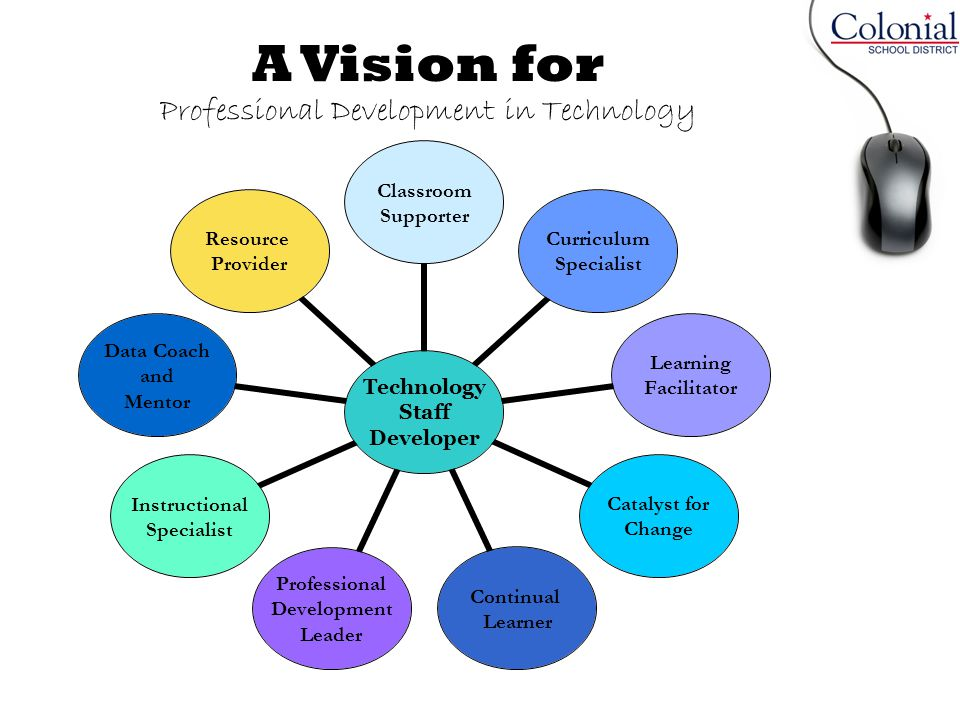How might the role of 'Learning Facilitator' contribute to creating an inclusive learning environment with the help of technology? The 'Learning Facilitator' plays a pivotal role in creating an inclusive learning environment by leveraging technology to accommodate diverse learning needs. They might implement adaptive learning software that adjusts to each student's pace and level of understanding, ensuring that all students receive personalized instruction. Additionally, they can promote the use of digital collaboration tools to foster a sense of community among students, encouraging participation from those who might be less inclined to speak up in a traditional classroom setting. By incorporating multimedia resources, the Learning Facilitator can also make content more accessible and engaging for students with different learning preferences and abilities. Can you give an example of a multimedia resource that might be particularly effective in engaging students? A particularly effective multimedia resource for engaging students could be interactive simulations or educational games. For instance, in a science class, students might use a virtual lab simulation to conduct experiments. This allows students to explore complex concepts in a hands-on, interactive manner without the limitations of physical lab space or resources. These simulations can provide immediate feedback and allow students to learn from trial and error, which is both engaging and educational. Additionally, digital storytelling tools, where students create their own multimedia presentations or videos, can help them to better understand and retain the subject matter by encouraging them to actively participate in the learning process. 